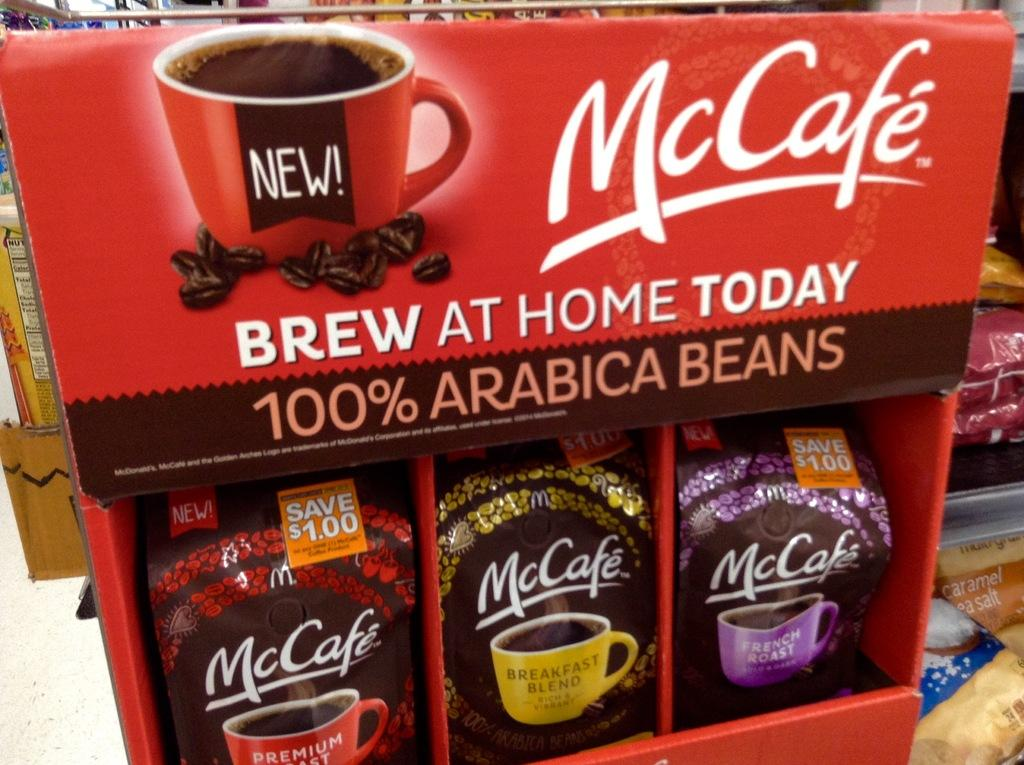What is inside the box in the image? There are packets inside the box in the image. What is depicted on the box? There is a cup image on the box. Are there any other packets visible in the image? Yes, there are additional packets beside the box. What type of plough is being used to harvest the packets in the image? There is no plough present in the image; it features a box with packets and an image of a cup. How much money is visible in the image? There is no money visible in the image; it features a box with packets and an image of a cup. 